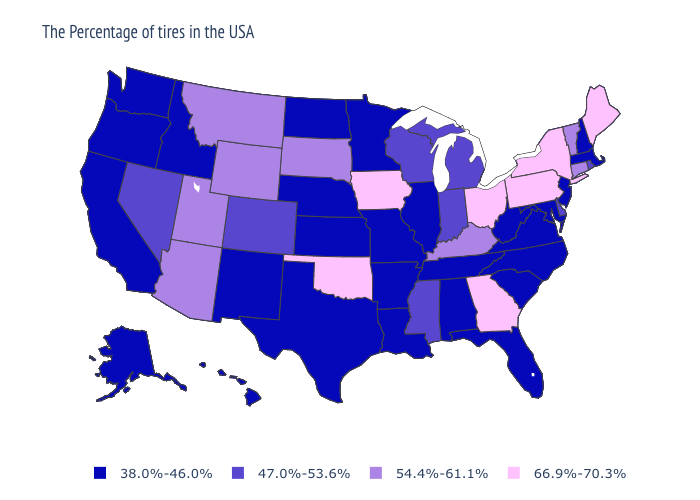Name the states that have a value in the range 54.4%-61.1%?
Answer briefly. Vermont, Connecticut, Kentucky, South Dakota, Wyoming, Utah, Montana, Arizona. How many symbols are there in the legend?
Quick response, please. 4. Does Washington have the highest value in the West?
Concise answer only. No. Among the states that border Ohio , which have the highest value?
Write a very short answer. Pennsylvania. Does Michigan have the highest value in the USA?
Short answer required. No. Name the states that have a value in the range 66.9%-70.3%?
Be succinct. Maine, New York, Pennsylvania, Ohio, Georgia, Iowa, Oklahoma. Does New Jersey have the lowest value in the Northeast?
Quick response, please. Yes. What is the value of Delaware?
Answer briefly. 47.0%-53.6%. What is the highest value in states that border Nebraska?
Write a very short answer. 66.9%-70.3%. What is the value of Maryland?
Give a very brief answer. 38.0%-46.0%. What is the value of North Dakota?
Keep it brief. 38.0%-46.0%. Which states have the lowest value in the USA?
Quick response, please. Massachusetts, New Hampshire, New Jersey, Maryland, Virginia, North Carolina, South Carolina, West Virginia, Florida, Alabama, Tennessee, Illinois, Louisiana, Missouri, Arkansas, Minnesota, Kansas, Nebraska, Texas, North Dakota, New Mexico, Idaho, California, Washington, Oregon, Alaska, Hawaii. Name the states that have a value in the range 47.0%-53.6%?
Write a very short answer. Rhode Island, Delaware, Michigan, Indiana, Wisconsin, Mississippi, Colorado, Nevada. What is the value of California?
Answer briefly. 38.0%-46.0%. 